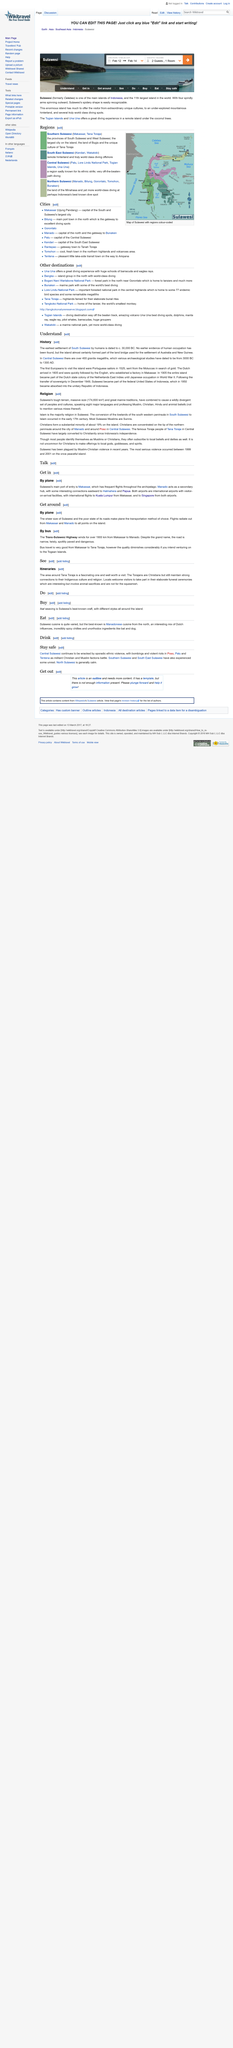Highlight a few significant elements in this photo. The Trans-Sulawesi Highway, which stretches between Makassar and Manado, is a distance of over 1,900 kilometers. The majority religion in Sulawesi is Islam. The first Europeans to visit the island were Portuguese sailors. Sulawesi, the 11th largest island in the world, is comparable in size to other notable islands around the globe. The two methods of transportation around Sulawesi that are discussed are plane and bus transportation. 